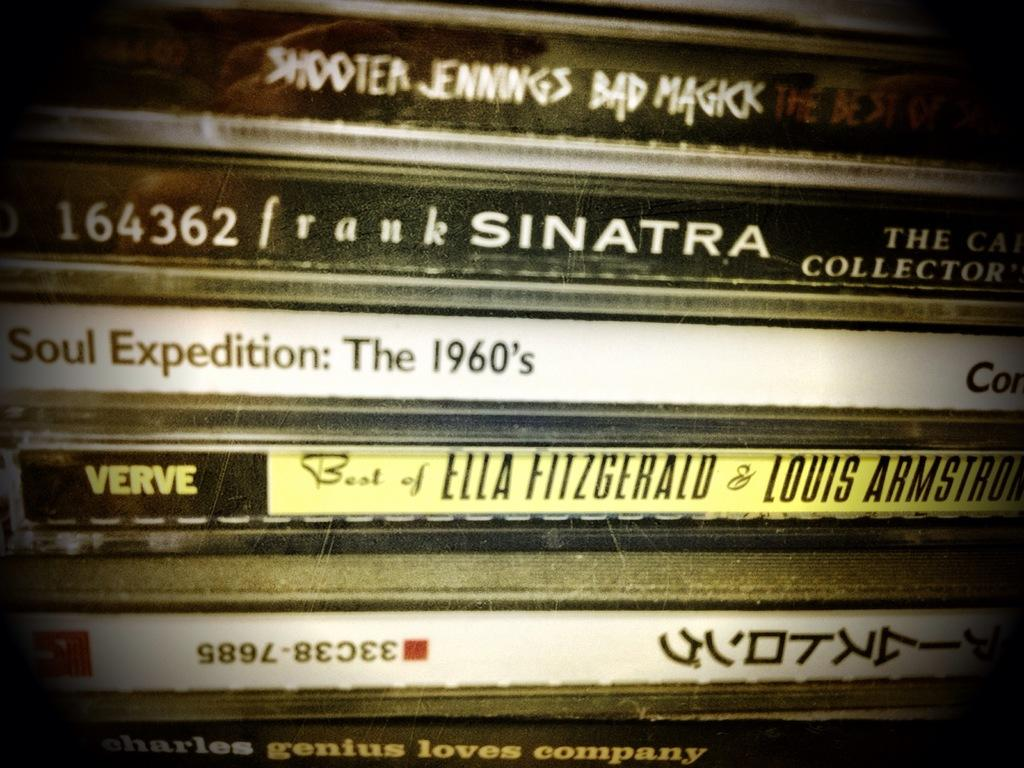Provide a one-sentence caption for the provided image. A stack of CDs including one of Frank Sinatra. 